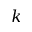<formula> <loc_0><loc_0><loc_500><loc_500>k</formula> 